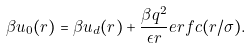Convert formula to latex. <formula><loc_0><loc_0><loc_500><loc_500>\beta u _ { 0 } ( r ) = \beta u _ { d } ( r ) + \frac { \beta q ^ { 2 } } { \epsilon r } { e r f c } ( r / \sigma ) .</formula> 